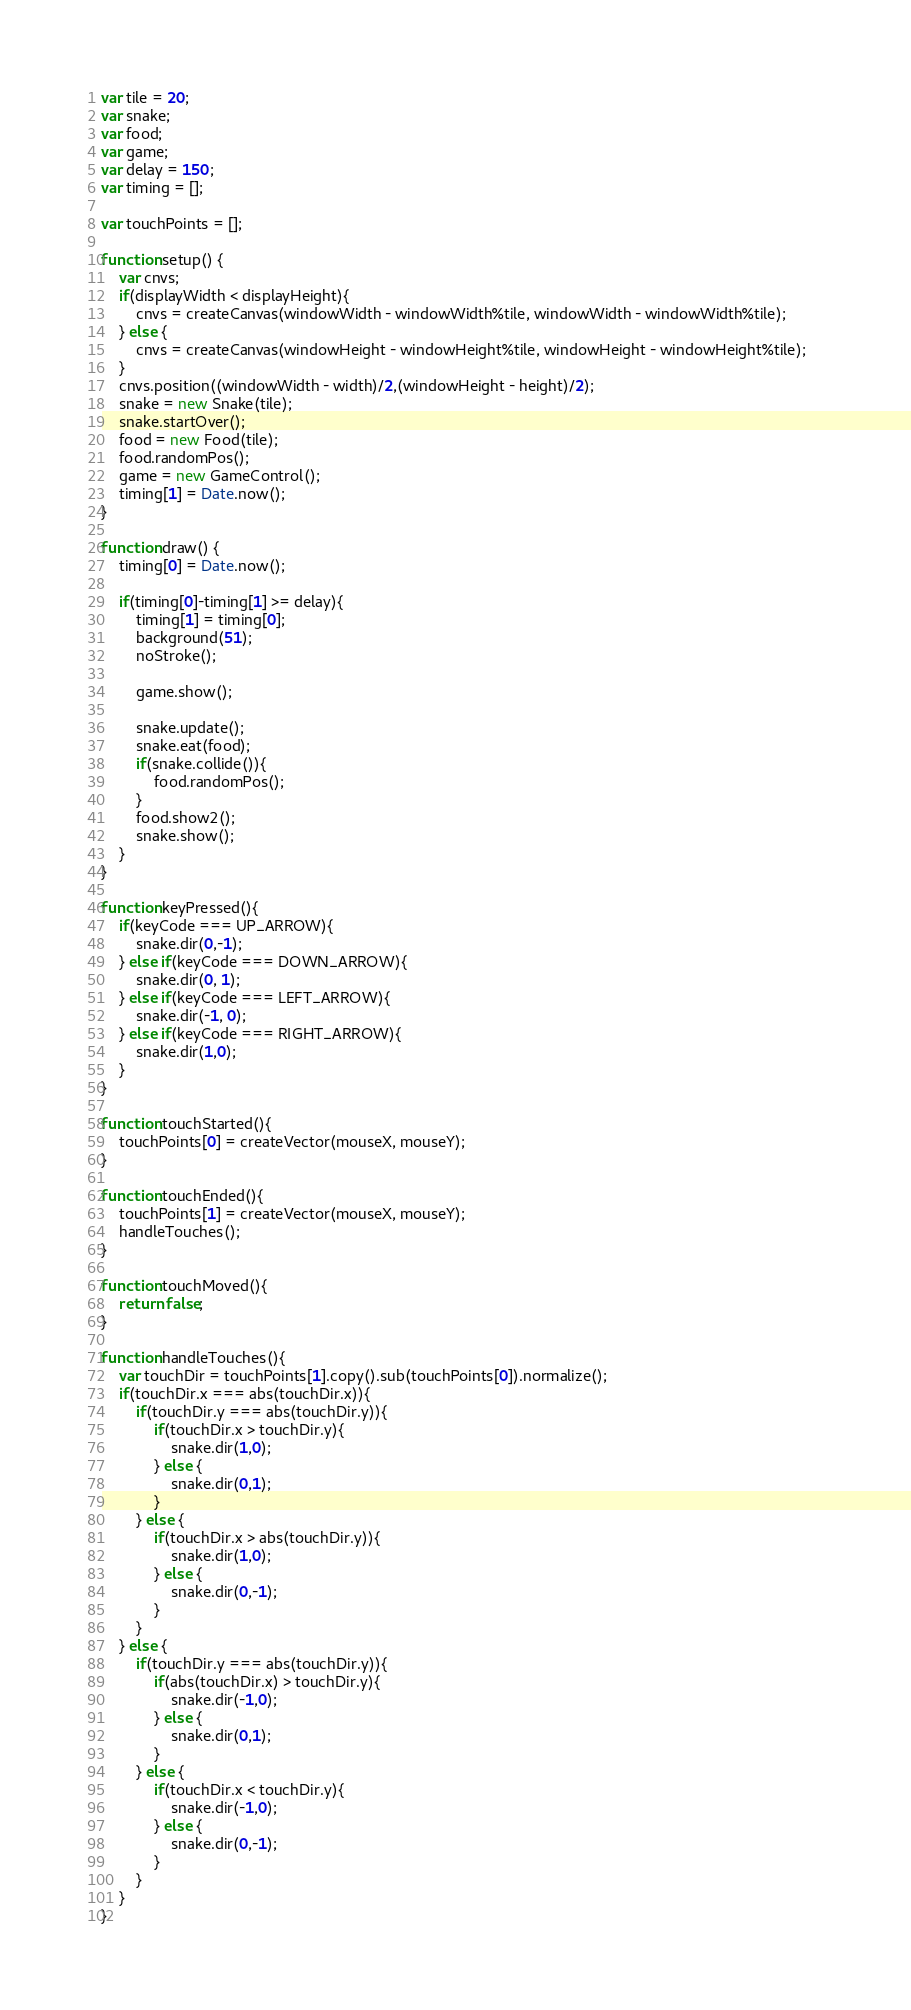Convert code to text. <code><loc_0><loc_0><loc_500><loc_500><_JavaScript_>var tile = 20;
var snake;
var food;
var game;
var delay = 150;
var timing = [];

var touchPoints = [];

function setup() {
	var cnvs;
	if(displayWidth < displayHeight){
		cnvs = createCanvas(windowWidth - windowWidth%tile, windowWidth - windowWidth%tile);
	} else {
		cnvs = createCanvas(windowHeight - windowHeight%tile, windowHeight - windowHeight%tile);	
	}
	cnvs.position((windowWidth - width)/2,(windowHeight - height)/2);
	snake = new Snake(tile);
	snake.startOver();
	food = new Food(tile);
	food.randomPos();
	game = new GameControl();
	timing[1] = Date.now();
}

function draw() {
	timing[0] = Date.now();

	if(timing[0]-timing[1] >= delay){
		timing[1] = timing[0];
		background(51);
		noStroke();

		game.show();

		snake.update();
		snake.eat(food);
		if(snake.collide()){
			food.randomPos();
		}
		food.show2();
		snake.show();
	}
}

function keyPressed(){
	if(keyCode === UP_ARROW){
		snake.dir(0,-1);
	} else if(keyCode === DOWN_ARROW){
		snake.dir(0, 1);
	} else if(keyCode === LEFT_ARROW){
		snake.dir(-1, 0);
	} else if(keyCode === RIGHT_ARROW){
		snake.dir(1,0);
	}
}

function touchStarted(){
	touchPoints[0] = createVector(mouseX, mouseY);
}

function touchEnded(){
	touchPoints[1] = createVector(mouseX, mouseY);
	handleTouches();
}

function touchMoved(){
	return false;
}

function handleTouches(){
	var touchDir = touchPoints[1].copy().sub(touchPoints[0]).normalize();
	if(touchDir.x === abs(touchDir.x)){
		if(touchDir.y === abs(touchDir.y)){
			if(touchDir.x > touchDir.y){
				snake.dir(1,0);
			} else {
				snake.dir(0,1);
			}
		} else {
			if(touchDir.x > abs(touchDir.y)){
				snake.dir(1,0);
			} else {
				snake.dir(0,-1);
			}
		}
	} else {
		if(touchDir.y === abs(touchDir.y)){
			if(abs(touchDir.x) > touchDir.y){
				snake.dir(-1,0);
			} else {
				snake.dir(0,1);
			}
		} else {
			if(touchDir.x < touchDir.y){
				snake.dir(-1,0);
			} else {
				snake.dir(0,-1);
			}
		}
	}
}</code> 